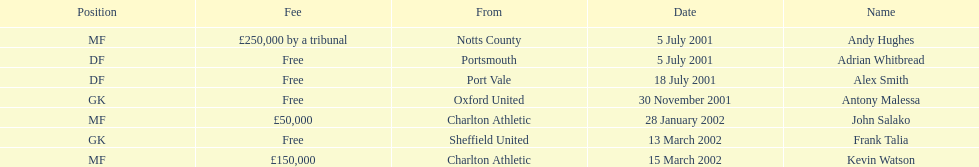Whos name is listed last on the chart? Kevin Watson. 